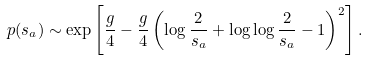Convert formula to latex. <formula><loc_0><loc_0><loc_500><loc_500>p ( s _ { a } ) \sim \exp \left [ \frac { g } { 4 } - \frac { g } { 4 } \left ( \log \frac { 2 } { s _ { a } } + \log \log \frac { 2 } { s _ { a } } - 1 \right ) ^ { 2 } \right ] .</formula> 